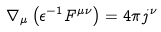<formula> <loc_0><loc_0><loc_500><loc_500>\nabla _ { \mu } \left ( \epsilon ^ { - 1 } F ^ { \mu \nu } \right ) = 4 \pi j ^ { \nu }</formula> 